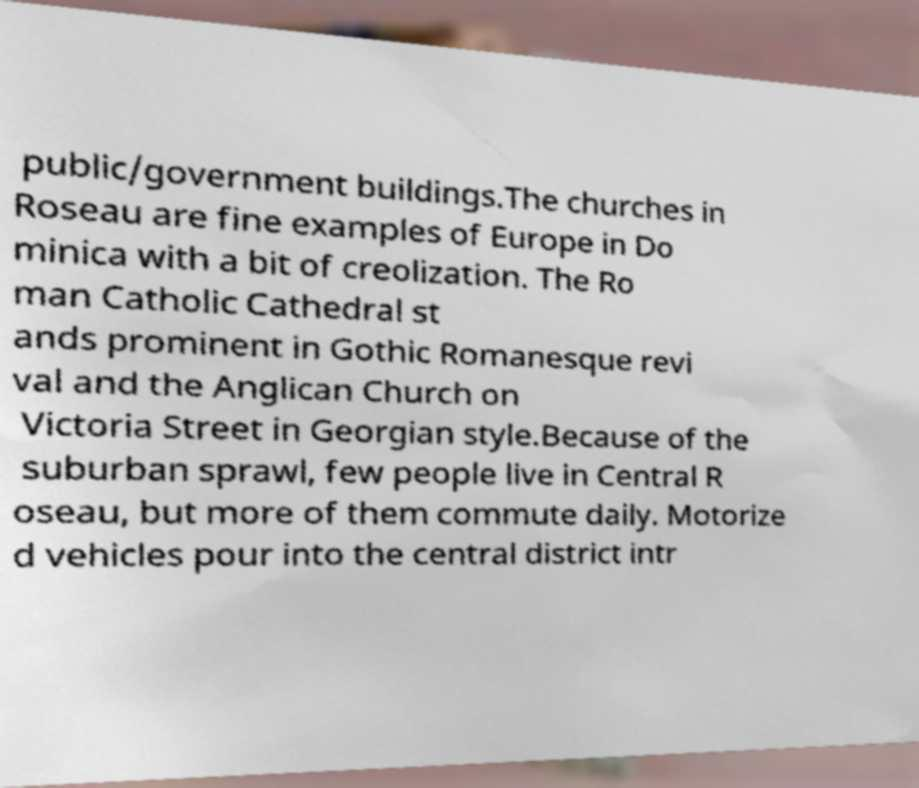Please identify and transcribe the text found in this image. public/government buildings.The churches in Roseau are fine examples of Europe in Do minica with a bit of creolization. The Ro man Catholic Cathedral st ands prominent in Gothic Romanesque revi val and the Anglican Church on Victoria Street in Georgian style.Because of the suburban sprawl, few people live in Central R oseau, but more of them commute daily. Motorize d vehicles pour into the central district intr 